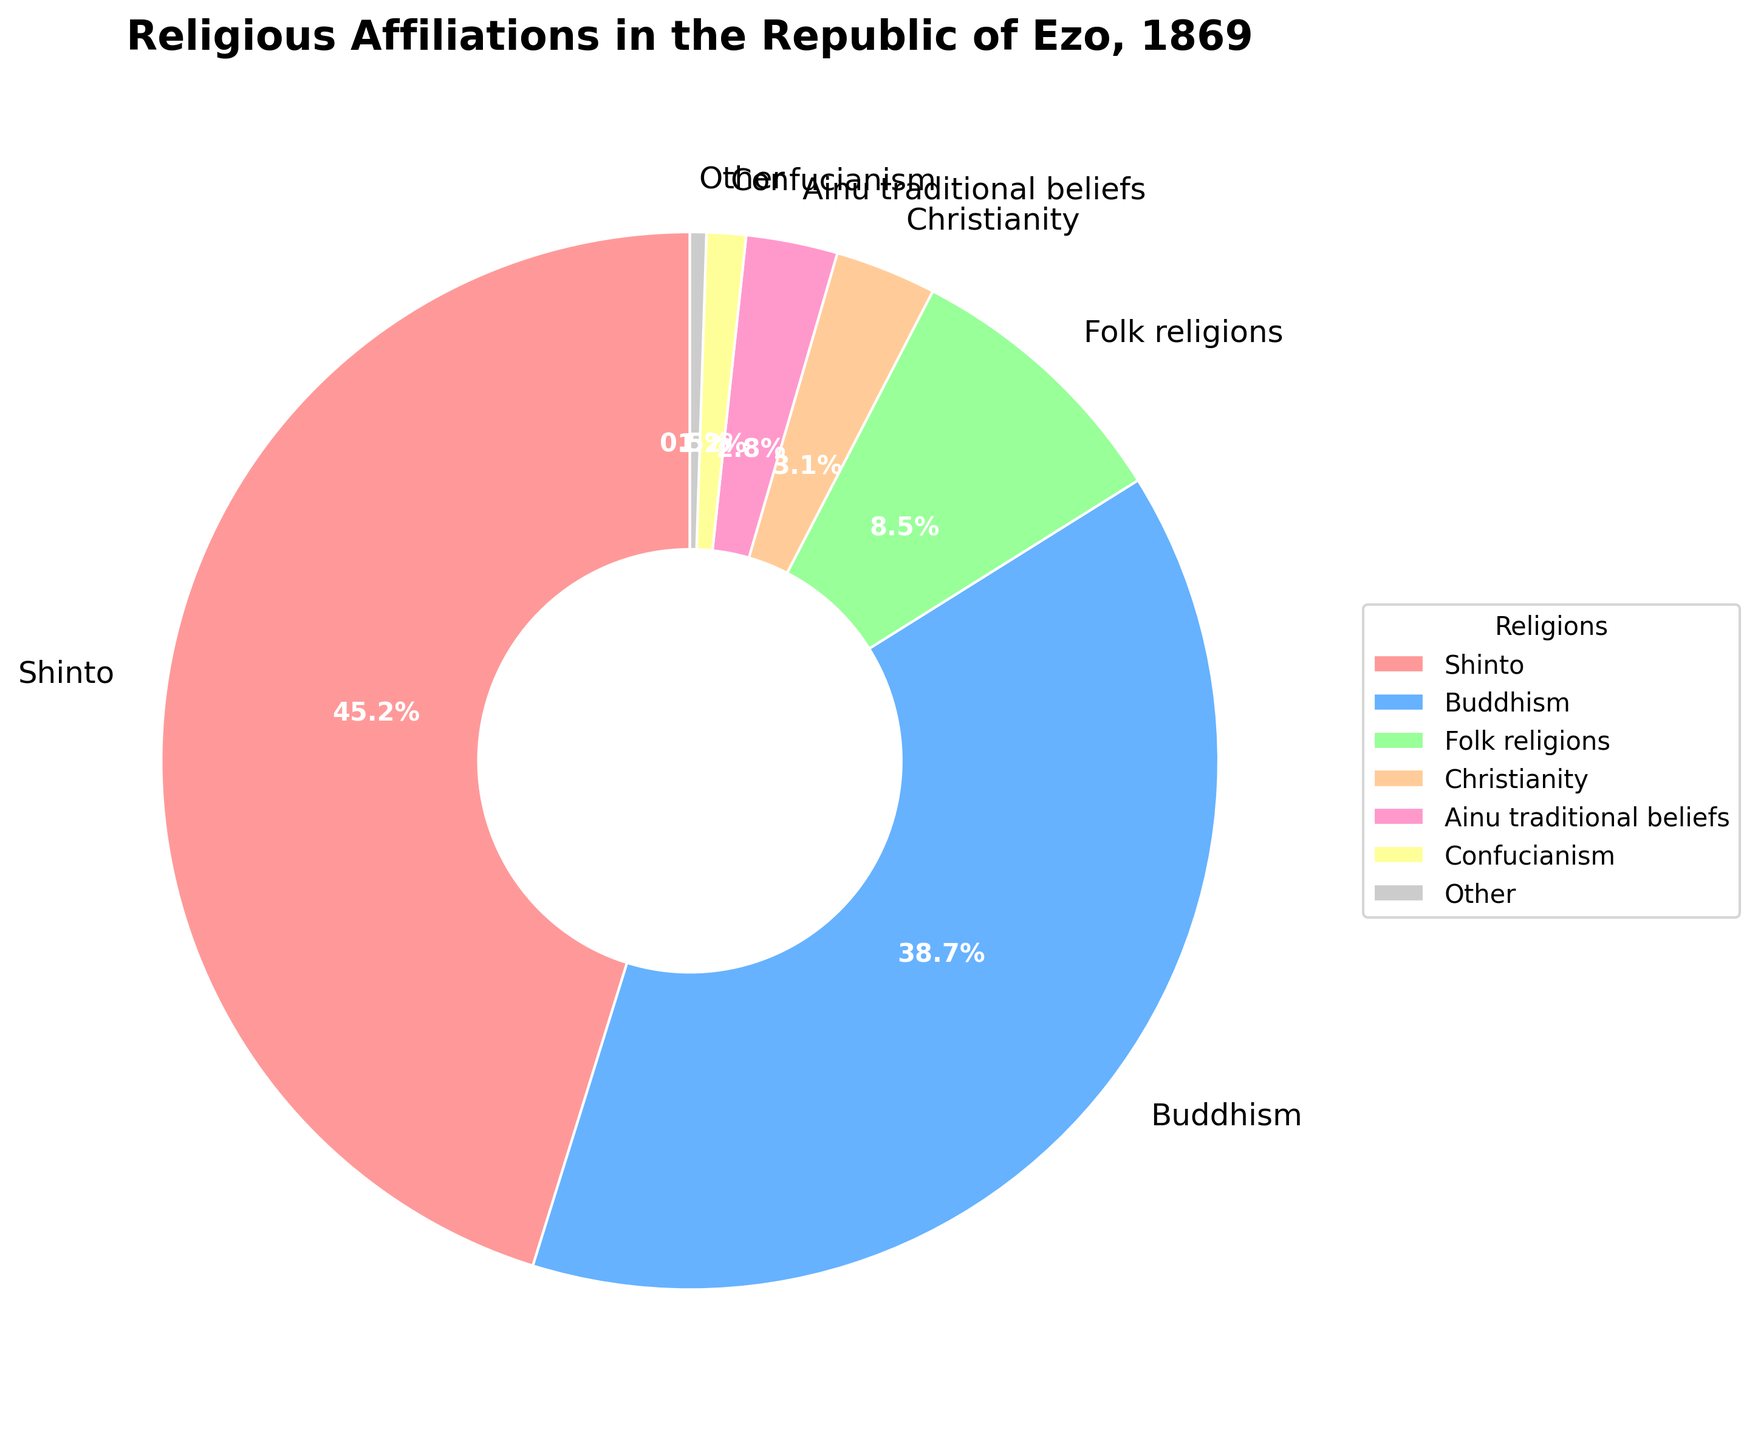Which religion has the largest affiliation percentage in the Republic of Ezo, 1869? To determine the largest affiliation percentage, look for the religion with the biggest slice in the pie chart. The slice labeled "Shinto" is the largest.
Answer: Shinto What is the combined percentage of Buddhism and Folk religions? Add the percentage of Buddhism (38.7%) and Folk religions (8.5%). The combined percentage is 38.7 + 8.5 = 47.2%.
Answer: 47.2% How does the percentage of Christianity compare to Confucianism? Compare the slice sizes or relevant labels. Christianity has a percentage of 3.1%, while Confucianism has 1.2%. 3.1% > 1.2%, so Christianity has a higher percentage than Confucianism.
Answer: Christianity has a higher percentage What is the sum of the percentages for religions other than Shinto and Buddhism? Sum the percentages for all religions except Shinto (45.2%) and Buddhism (38.7%). The other percentages are 8.5%, 3.1%, 2.8%, 1.2%, and 0.5%. The combined sum is 8.5 + 3.1 + 2.8 + 1.2 + 0.5 = 16.1%.
Answer: 16.1% Which religion has the smallest affiliation percentage and what is that percentage? Identify the smallest slice in the pie chart. The slice labeled "Other" is the smallest, indicating a percentage of 0.5%.
Answer: Other, 0.5% How many religions have an affiliation percentage greater than 5%? Count the number of slices with percentages greater than 5%. These are Shinto (45.2%) and Buddhism (38.7%). Two slices fit this criterion.
Answer: 2 What is the percentage difference between the largest and smallest religious affiliations? Subtract the smallest percentage from the largest. Largest is 45.2% (Shinto) and smallest is 0.5% (Other). The difference is 45.2 - 0.5 = 44.7%.
Answer: 44.7% Which two religions combined have an affiliation percentage closest to 50%? Calculate the combined percentages of different pairs and find the pair closest to 50%. Buddhism (38.7%) and Folk religions (8.5%) combine to 47.2%, which is closest to 50%.
Answer: Buddhism and Folk religions What is the average percentage of affiliations among Ainu traditional beliefs, Confucianism, and Other? Calculate the average of Ainu traditional beliefs (2.8%), Confucianism (1.2%), and Other (0.5%). The average is (2.8 + 1.2 + 0.5) / 3 ≈ 1.5%.
Answer: 1.5% 